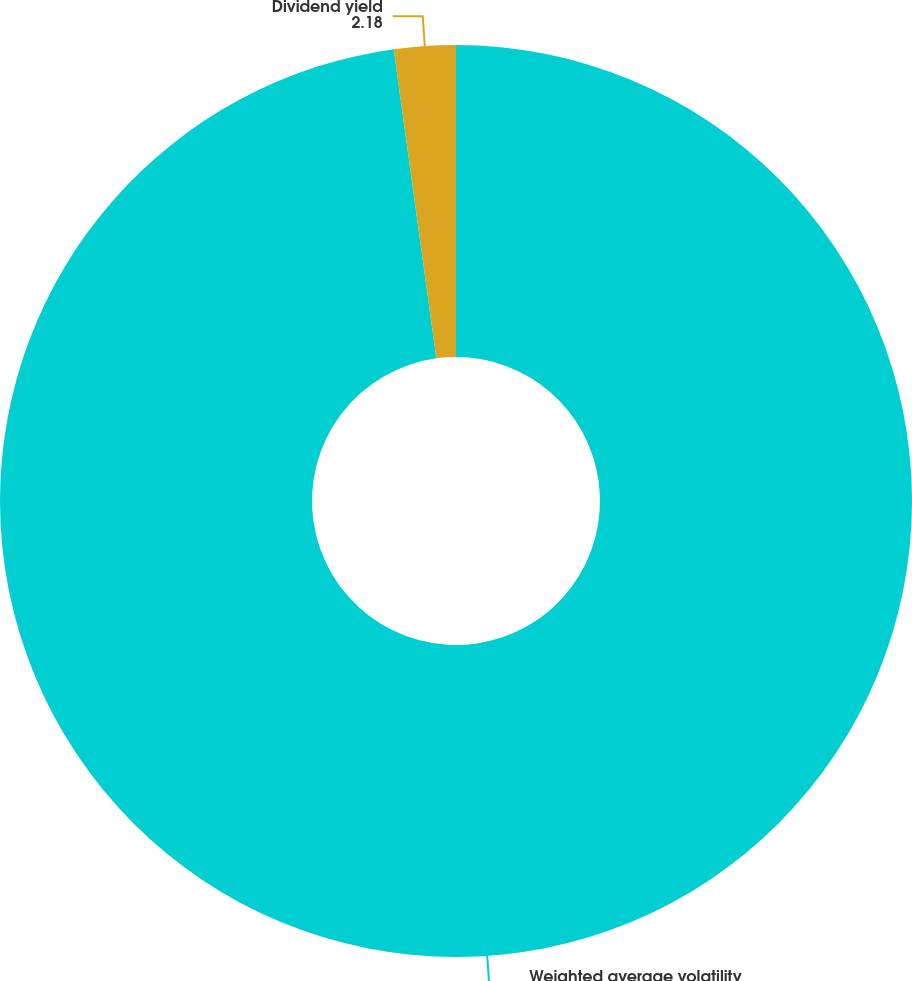Convert chart. <chart><loc_0><loc_0><loc_500><loc_500><pie_chart><fcel>Weighted average volatility<fcel>Dividend yield<nl><fcel>97.82%<fcel>2.18%<nl></chart> 